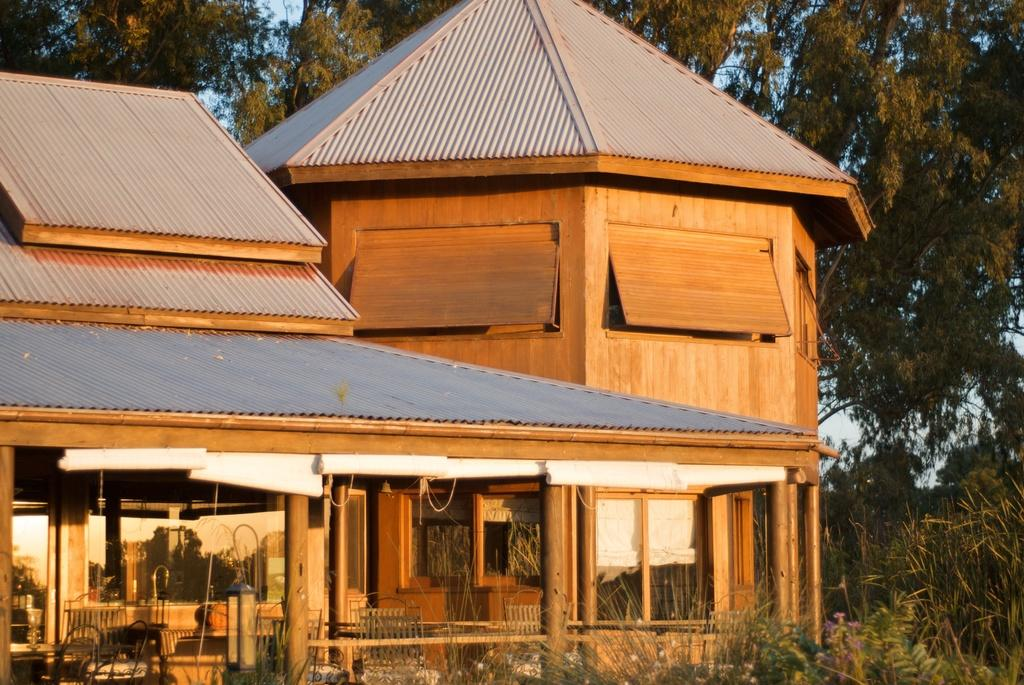What type of structure is visible in the image? There is a house in the image. What furniture is present at the bottom of the image? There are chairs and tables at the bottom of the image. What can be seen in the background of the image? There are trees and plants in the background of the image. What type of copper net can be seen holding the grapes in the image? There is no copper net or grapes present in the image. 